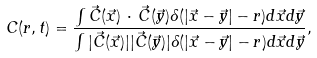<formula> <loc_0><loc_0><loc_500><loc_500>C ( r , t ) = \frac { \int { \vec { C } } ( { \vec { x } } ) \, \cdot \, { \vec { C } } ( { \vec { y } } ) \delta ( | { \vec { x } } - { \vec { y } } | - r ) d { \vec { x } } d { \vec { y } } } { \int | { \vec { C } } ( { \vec { x } } ) | | { \vec { C } } ( { \vec { y } } ) | \delta ( | { \vec { x } } - { \vec { y } } | - r ) d { \vec { x } } d { \vec { y } } } ,</formula> 